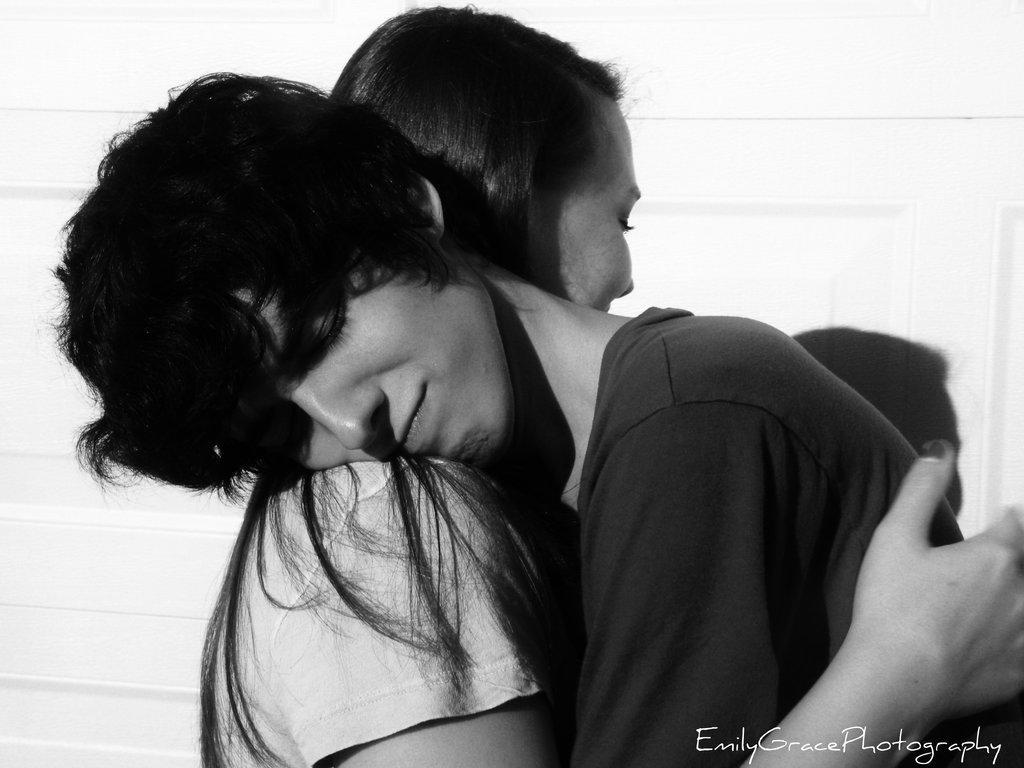Describe this image in one or two sentences. In this image there is a man at right side of this image and left side one is women, and there is a watermark text written at bottom right corner of this image. 